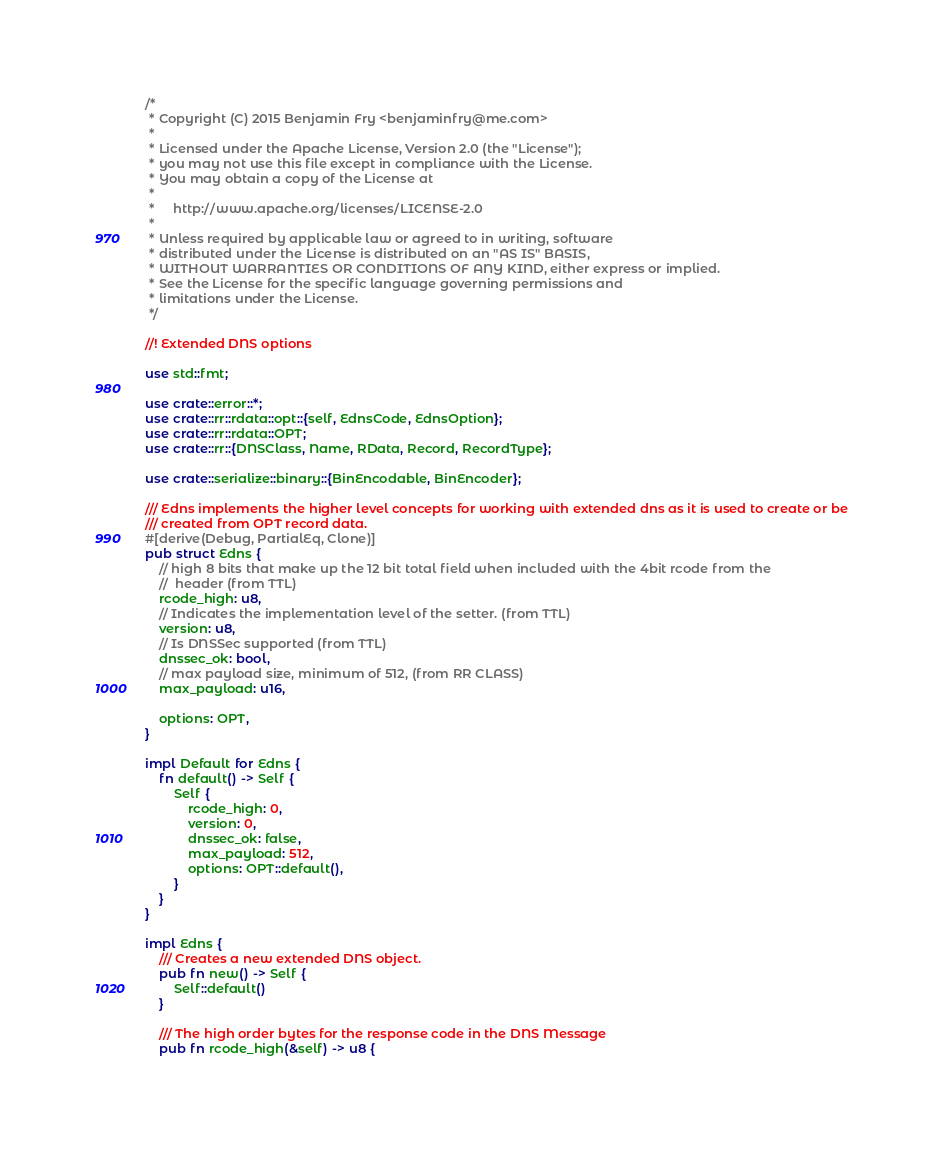Convert code to text. <code><loc_0><loc_0><loc_500><loc_500><_Rust_>/*
 * Copyright (C) 2015 Benjamin Fry <benjaminfry@me.com>
 *
 * Licensed under the Apache License, Version 2.0 (the "License");
 * you may not use this file except in compliance with the License.
 * You may obtain a copy of the License at
 *
 *     http://www.apache.org/licenses/LICENSE-2.0
 *
 * Unless required by applicable law or agreed to in writing, software
 * distributed under the License is distributed on an "AS IS" BASIS,
 * WITHOUT WARRANTIES OR CONDITIONS OF ANY KIND, either express or implied.
 * See the License for the specific language governing permissions and
 * limitations under the License.
 */

//! Extended DNS options

use std::fmt;

use crate::error::*;
use crate::rr::rdata::opt::{self, EdnsCode, EdnsOption};
use crate::rr::rdata::OPT;
use crate::rr::{DNSClass, Name, RData, Record, RecordType};

use crate::serialize::binary::{BinEncodable, BinEncoder};

/// Edns implements the higher level concepts for working with extended dns as it is used to create or be
/// created from OPT record data.
#[derive(Debug, PartialEq, Clone)]
pub struct Edns {
    // high 8 bits that make up the 12 bit total field when included with the 4bit rcode from the
    //  header (from TTL)
    rcode_high: u8,
    // Indicates the implementation level of the setter. (from TTL)
    version: u8,
    // Is DNSSec supported (from TTL)
    dnssec_ok: bool,
    // max payload size, minimum of 512, (from RR CLASS)
    max_payload: u16,

    options: OPT,
}

impl Default for Edns {
    fn default() -> Self {
        Self {
            rcode_high: 0,
            version: 0,
            dnssec_ok: false,
            max_payload: 512,
            options: OPT::default(),
        }
    }
}

impl Edns {
    /// Creates a new extended DNS object.
    pub fn new() -> Self {
        Self::default()
    }

    /// The high order bytes for the response code in the DNS Message
    pub fn rcode_high(&self) -> u8 {</code> 